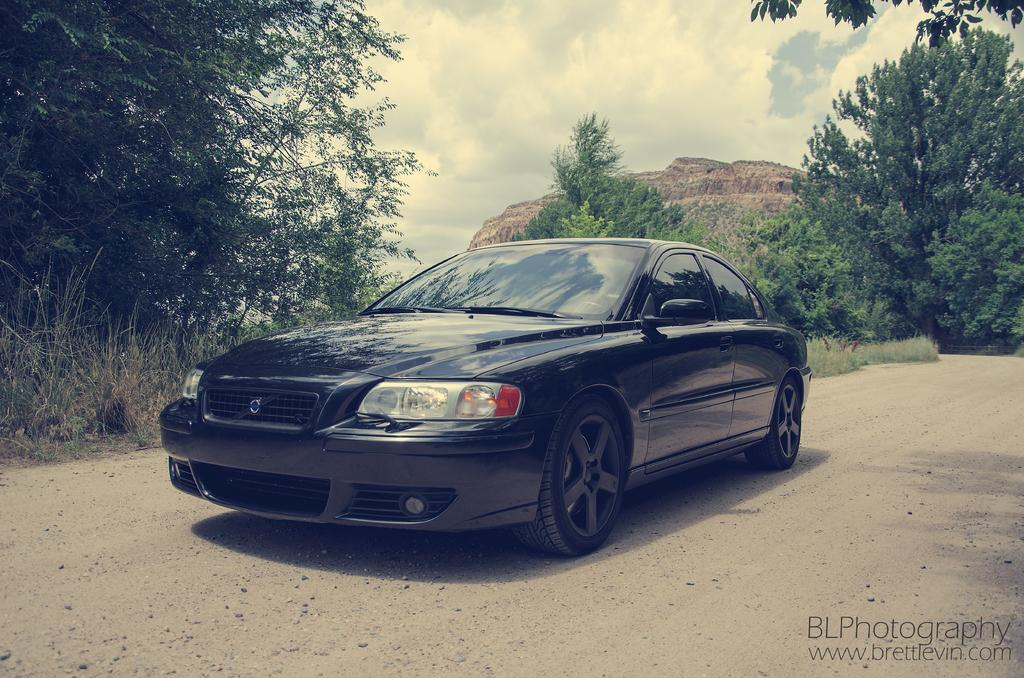What is the main subject of the image? There is a car at the center of the image. Is there any text or logo visible in the image? Yes, there is a watermark in the bottom right-hand side of the image. What can be seen in the background of the image? There are trees in the background of the image. What is visible at the top of the image? The sky is visible at the top of the image. What type of pot is being used to hold the can of seeds in the image? There is no pot, can, or seeds present in the image. 